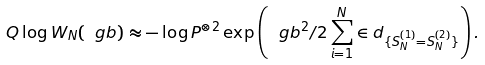Convert formula to latex. <formula><loc_0><loc_0><loc_500><loc_500>Q \log W _ { N } ( \ g b ) \approx - \log P ^ { \otimes 2 } \exp \left ( \ g b ^ { 2 } / 2 \sum _ { i = 1 } ^ { N } \in d _ { \{ S _ { N } ^ { ( 1 ) } = S _ { N } ^ { ( 2 ) } \} } \right ) .</formula> 